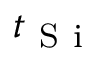Convert formula to latex. <formula><loc_0><loc_0><loc_500><loc_500>t _ { S i }</formula> 